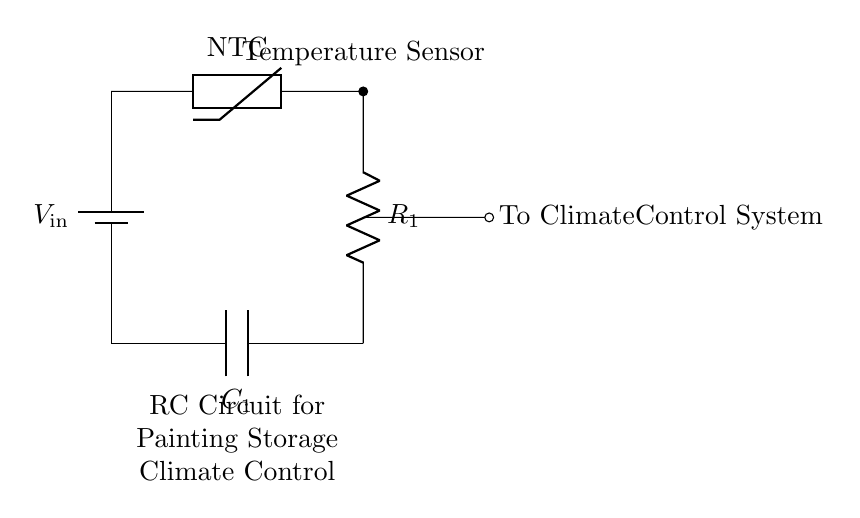What type of temperature sensor is used in this circuit? The circuit includes an NTC thermistor as the temperature sensor, indicated in the diagram. NTC stands for Negative Temperature Coefficient, meaning its resistance decreases with increasing temperature.
Answer: NTC What is the function of capacitor C1 in this circuit? C1 acts as a filter that smooths out voltage fluctuations, helping to ensure stable output to the climate control system. The capacitor temporarily stores charge and releases it when needed, which helps maintain a consistent voltage.
Answer: Filter What is the main purpose of this RC circuit? The primary goal of the circuit is to sense temperature and control the climate for the preservation of paintings, as indicated by the output connection to a climate control system.
Answer: Climate control What component provides the input voltage? The input voltage is supplied by the battery, labeled as "V_in" in the circuit. Batteries are commonly used for portable and constant voltage supply in circuits like this.
Answer: Battery What type of circuit is this? This circuit is classified as a resistor-capacitor (RC) circuit, which is designed for timing and smoothing signals within electronic systems, in this case, for climate control applications.
Answer: RC circuit How does the resistor R1 relate to the temperature sensing? Resistor R1 forms a voltage divider with the thermistor, allowing changes in resistance due to temperature variations to be translated into voltage changes, which can then be read by the climate control system.
Answer: Voltage divider 